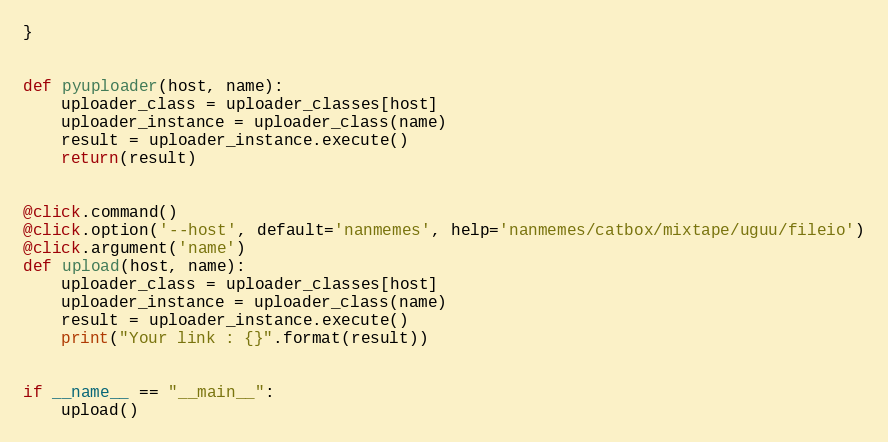Convert code to text. <code><loc_0><loc_0><loc_500><loc_500><_Python_>}


def pyuploader(host, name):
    uploader_class = uploader_classes[host]
    uploader_instance = uploader_class(name)
    result = uploader_instance.execute()
    return(result)


@click.command()
@click.option('--host', default='nanmemes', help='nanmemes/catbox/mixtape/uguu/fileio')
@click.argument('name')
def upload(host, name):
    uploader_class = uploader_classes[host]
    uploader_instance = uploader_class(name)
    result = uploader_instance.execute()
    print("Your link : {}".format(result))


if __name__ == "__main__":
    upload()
</code> 